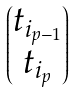<formula> <loc_0><loc_0><loc_500><loc_500>\begin{pmatrix} t _ { i _ { p - 1 } } \\ t _ { i _ { p } } \end{pmatrix}</formula> 